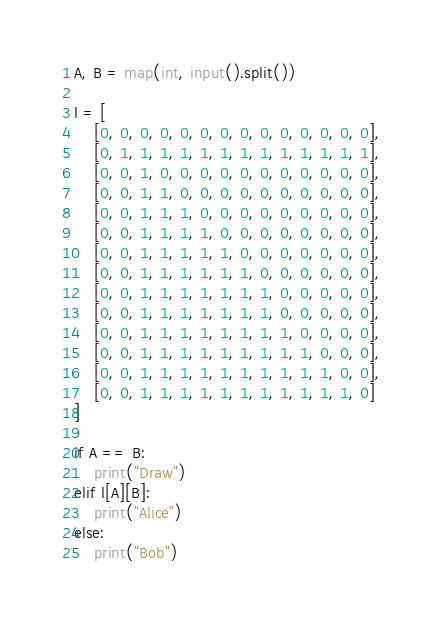<code> <loc_0><loc_0><loc_500><loc_500><_Python_>A, B = map(int, input().split())

l = [
    [0, 0, 0, 0, 0, 0, 0, 0, 0, 0, 0, 0, 0, 0],
    [0, 1, 1, 1, 1, 1, 1, 1, 1, 1, 1, 1, 1, 1],
    [0, 0, 1, 0, 0, 0, 0, 0, 0, 0, 0, 0, 0, 0],
    [0, 0, 1, 1, 0, 0, 0, 0, 0, 0, 0, 0, 0, 0],
    [0, 0, 1, 1, 1, 0, 0, 0, 0, 0, 0, 0, 0, 0],
    [0, 0, 1, 1, 1, 1, 0, 0, 0, 0, 0, 0, 0, 0],
    [0, 0, 1, 1, 1, 1, 1, 0, 0, 0, 0, 0, 0, 0],
    [0, 0, 1, 1, 1, 1, 1, 1, 0, 0, 0, 0, 0, 0],
    [0, 0, 1, 1, 1, 1, 1, 1, 1, 0, 0, 0, 0, 0],
    [0, 0, 1, 1, 1, 1, 1, 1, 1, 0, 0, 0, 0, 0],
    [0, 0, 1, 1, 1, 1, 1, 1, 1, 1, 0, 0, 0, 0],
    [0, 0, 1, 1, 1, 1, 1, 1, 1, 1, 1, 0, 0, 0],
    [0, 0, 1, 1, 1, 1, 1, 1, 1, 1, 1, 1, 0, 0],
    [0, 0, 1, 1, 1, 1, 1, 1, 1, 1, 1, 1, 1, 0]
]

if A == B:
    print("Draw")
elif l[A][B]:
    print("Alice")
else:
    print("Bob")</code> 